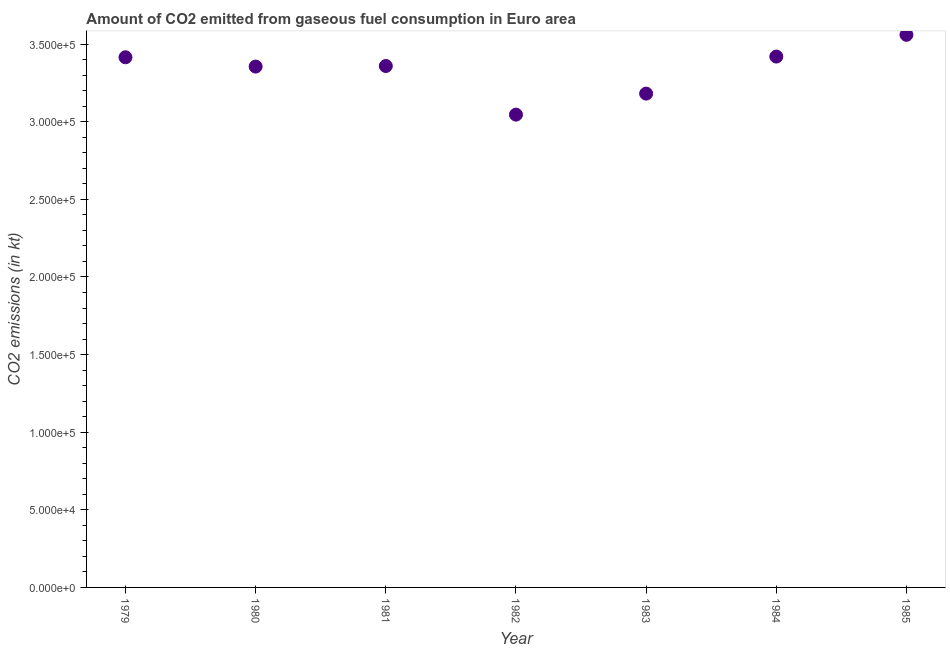What is the co2 emissions from gaseous fuel consumption in 1979?
Provide a short and direct response. 3.42e+05. Across all years, what is the maximum co2 emissions from gaseous fuel consumption?
Your answer should be compact. 3.56e+05. Across all years, what is the minimum co2 emissions from gaseous fuel consumption?
Offer a terse response. 3.05e+05. In which year was the co2 emissions from gaseous fuel consumption minimum?
Your response must be concise. 1982. What is the sum of the co2 emissions from gaseous fuel consumption?
Give a very brief answer. 2.33e+06. What is the difference between the co2 emissions from gaseous fuel consumption in 1981 and 1982?
Offer a very short reply. 3.13e+04. What is the average co2 emissions from gaseous fuel consumption per year?
Provide a succinct answer. 3.33e+05. What is the median co2 emissions from gaseous fuel consumption?
Your answer should be compact. 3.36e+05. In how many years, is the co2 emissions from gaseous fuel consumption greater than 230000 kt?
Your answer should be compact. 7. What is the ratio of the co2 emissions from gaseous fuel consumption in 1979 to that in 1981?
Ensure brevity in your answer.  1.02. Is the co2 emissions from gaseous fuel consumption in 1981 less than that in 1983?
Give a very brief answer. No. Is the difference between the co2 emissions from gaseous fuel consumption in 1982 and 1983 greater than the difference between any two years?
Ensure brevity in your answer.  No. What is the difference between the highest and the second highest co2 emissions from gaseous fuel consumption?
Your response must be concise. 1.40e+04. Is the sum of the co2 emissions from gaseous fuel consumption in 1984 and 1985 greater than the maximum co2 emissions from gaseous fuel consumption across all years?
Give a very brief answer. Yes. What is the difference between the highest and the lowest co2 emissions from gaseous fuel consumption?
Ensure brevity in your answer.  5.14e+04. In how many years, is the co2 emissions from gaseous fuel consumption greater than the average co2 emissions from gaseous fuel consumption taken over all years?
Your answer should be very brief. 5. How many years are there in the graph?
Offer a very short reply. 7. What is the difference between two consecutive major ticks on the Y-axis?
Offer a terse response. 5.00e+04. Are the values on the major ticks of Y-axis written in scientific E-notation?
Your response must be concise. Yes. Does the graph contain grids?
Give a very brief answer. No. What is the title of the graph?
Ensure brevity in your answer.  Amount of CO2 emitted from gaseous fuel consumption in Euro area. What is the label or title of the X-axis?
Your response must be concise. Year. What is the label or title of the Y-axis?
Provide a short and direct response. CO2 emissions (in kt). What is the CO2 emissions (in kt) in 1979?
Ensure brevity in your answer.  3.42e+05. What is the CO2 emissions (in kt) in 1980?
Provide a succinct answer. 3.36e+05. What is the CO2 emissions (in kt) in 1981?
Your answer should be compact. 3.36e+05. What is the CO2 emissions (in kt) in 1982?
Give a very brief answer. 3.05e+05. What is the CO2 emissions (in kt) in 1983?
Give a very brief answer. 3.18e+05. What is the CO2 emissions (in kt) in 1984?
Your answer should be compact. 3.42e+05. What is the CO2 emissions (in kt) in 1985?
Your answer should be compact. 3.56e+05. What is the difference between the CO2 emissions (in kt) in 1979 and 1980?
Keep it short and to the point. 5991.36. What is the difference between the CO2 emissions (in kt) in 1979 and 1981?
Your answer should be very brief. 5625.69. What is the difference between the CO2 emissions (in kt) in 1979 and 1982?
Ensure brevity in your answer.  3.69e+04. What is the difference between the CO2 emissions (in kt) in 1979 and 1983?
Provide a succinct answer. 2.34e+04. What is the difference between the CO2 emissions (in kt) in 1979 and 1984?
Provide a succinct answer. -459.92. What is the difference between the CO2 emissions (in kt) in 1979 and 1985?
Provide a short and direct response. -1.45e+04. What is the difference between the CO2 emissions (in kt) in 1980 and 1981?
Offer a very short reply. -365.67. What is the difference between the CO2 emissions (in kt) in 1980 and 1982?
Offer a very short reply. 3.10e+04. What is the difference between the CO2 emissions (in kt) in 1980 and 1983?
Provide a short and direct response. 1.74e+04. What is the difference between the CO2 emissions (in kt) in 1980 and 1984?
Offer a terse response. -6451.28. What is the difference between the CO2 emissions (in kt) in 1980 and 1985?
Keep it short and to the point. -2.05e+04. What is the difference between the CO2 emissions (in kt) in 1981 and 1982?
Your answer should be compact. 3.13e+04. What is the difference between the CO2 emissions (in kt) in 1981 and 1983?
Keep it short and to the point. 1.78e+04. What is the difference between the CO2 emissions (in kt) in 1981 and 1984?
Your answer should be very brief. -6085.61. What is the difference between the CO2 emissions (in kt) in 1981 and 1985?
Make the answer very short. -2.01e+04. What is the difference between the CO2 emissions (in kt) in 1982 and 1983?
Provide a short and direct response. -1.35e+04. What is the difference between the CO2 emissions (in kt) in 1982 and 1984?
Provide a succinct answer. -3.74e+04. What is the difference between the CO2 emissions (in kt) in 1982 and 1985?
Your answer should be compact. -5.14e+04. What is the difference between the CO2 emissions (in kt) in 1983 and 1984?
Your response must be concise. -2.39e+04. What is the difference between the CO2 emissions (in kt) in 1983 and 1985?
Provide a short and direct response. -3.79e+04. What is the difference between the CO2 emissions (in kt) in 1984 and 1985?
Provide a succinct answer. -1.40e+04. What is the ratio of the CO2 emissions (in kt) in 1979 to that in 1980?
Provide a succinct answer. 1.02. What is the ratio of the CO2 emissions (in kt) in 1979 to that in 1982?
Ensure brevity in your answer.  1.12. What is the ratio of the CO2 emissions (in kt) in 1979 to that in 1983?
Keep it short and to the point. 1.07. What is the ratio of the CO2 emissions (in kt) in 1979 to that in 1984?
Offer a terse response. 1. What is the ratio of the CO2 emissions (in kt) in 1980 to that in 1982?
Provide a short and direct response. 1.1. What is the ratio of the CO2 emissions (in kt) in 1980 to that in 1983?
Provide a succinct answer. 1.05. What is the ratio of the CO2 emissions (in kt) in 1980 to that in 1984?
Offer a terse response. 0.98. What is the ratio of the CO2 emissions (in kt) in 1980 to that in 1985?
Give a very brief answer. 0.94. What is the ratio of the CO2 emissions (in kt) in 1981 to that in 1982?
Make the answer very short. 1.1. What is the ratio of the CO2 emissions (in kt) in 1981 to that in 1983?
Your answer should be very brief. 1.06. What is the ratio of the CO2 emissions (in kt) in 1981 to that in 1985?
Your response must be concise. 0.94. What is the ratio of the CO2 emissions (in kt) in 1982 to that in 1984?
Your response must be concise. 0.89. What is the ratio of the CO2 emissions (in kt) in 1982 to that in 1985?
Your answer should be compact. 0.86. What is the ratio of the CO2 emissions (in kt) in 1983 to that in 1984?
Your response must be concise. 0.93. What is the ratio of the CO2 emissions (in kt) in 1983 to that in 1985?
Your response must be concise. 0.89. 